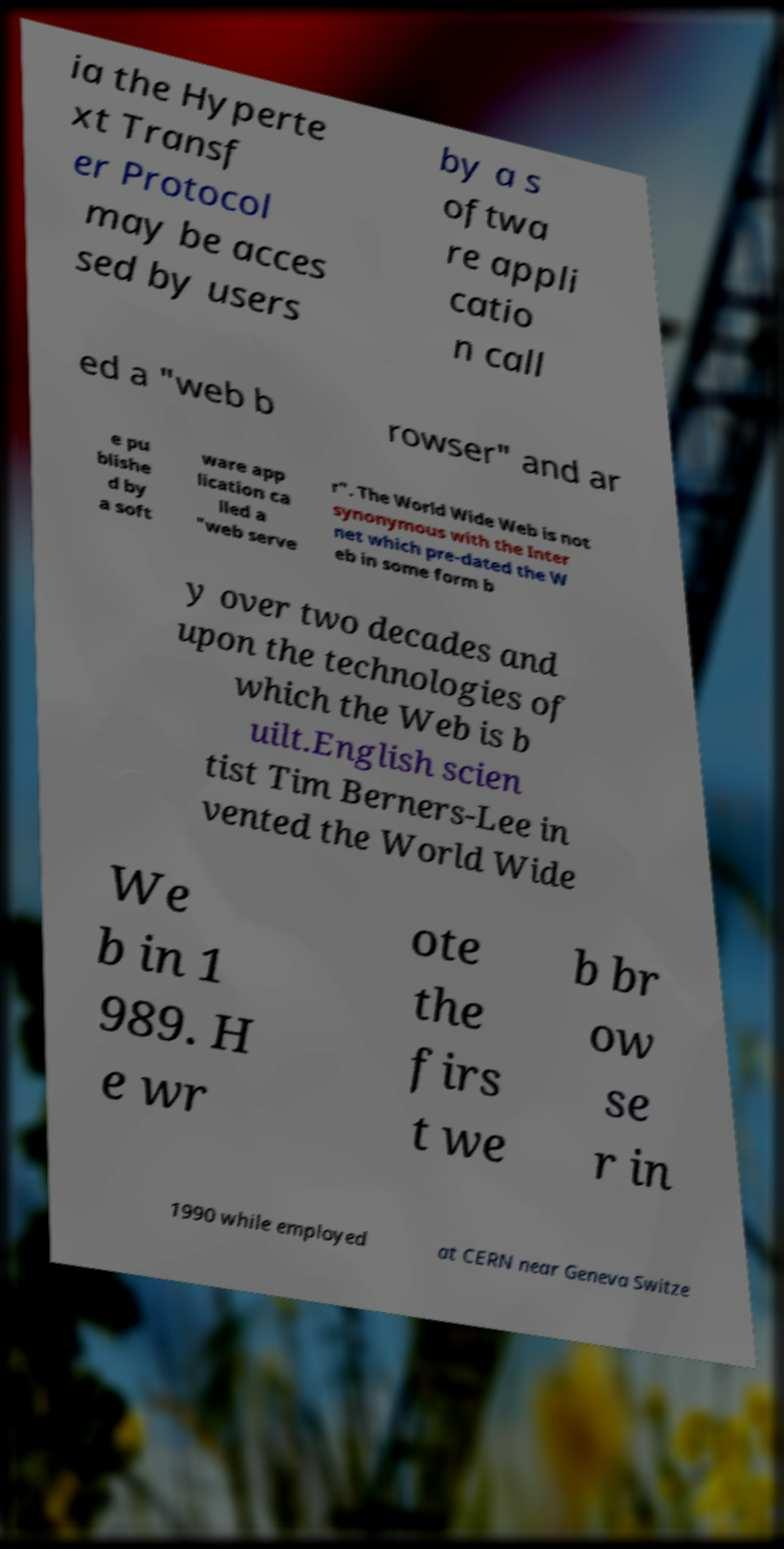Please identify and transcribe the text found in this image. ia the Hyperte xt Transf er Protocol may be acces sed by users by a s oftwa re appli catio n call ed a "web b rowser" and ar e pu blishe d by a soft ware app lication ca lled a "web serve r". The World Wide Web is not synonymous with the Inter net which pre-dated the W eb in some form b y over two decades and upon the technologies of which the Web is b uilt.English scien tist Tim Berners-Lee in vented the World Wide We b in 1 989. H e wr ote the firs t we b br ow se r in 1990 while employed at CERN near Geneva Switze 